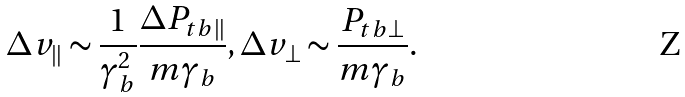Convert formula to latex. <formula><loc_0><loc_0><loc_500><loc_500>\Delta v _ { \| } \sim \frac { 1 } { \gamma _ { b } ^ { 2 } } \frac { \Delta P _ { t b \| } } { m \gamma _ { b } } , \Delta v _ { \perp } \sim \frac { P _ { t b \perp } } { m \gamma _ { b } } .</formula> 